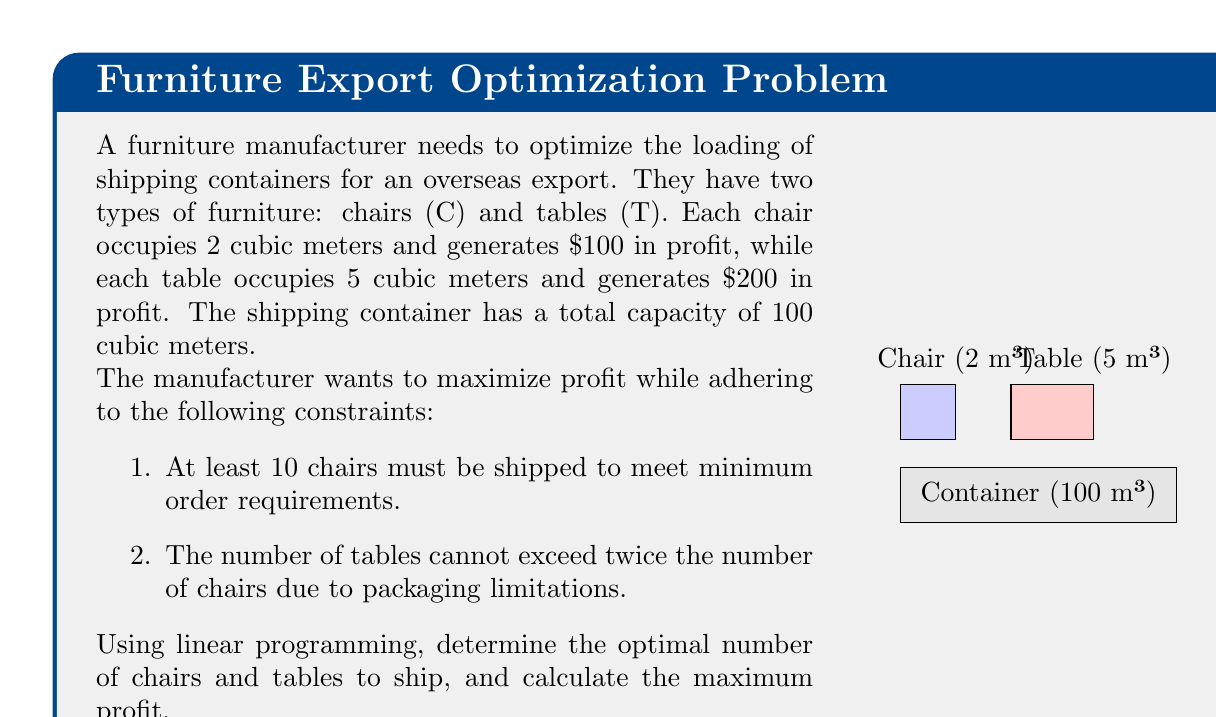Solve this math problem. Let's solve this problem step by step using linear programming:

1. Define variables:
   Let $x$ be the number of chairs and $y$ be the number of tables.

2. Objective function:
   Maximize profit: $Z = 100x + 200y$

3. Constraints:
   a. Space constraint: $2x + 5y \leq 100$ (total space ≤ 100 m³)
   b. Minimum chair requirement: $x \geq 10$
   c. Table-to-chair ratio: $y \leq 2x$
   d. Non-negativity: $x \geq 0, y \geq 0$

4. Set up the linear programming problem:
   Maximize $Z = 100x + 200y$
   Subject to:
   $2x + 5y \leq 100$
   $x \geq 10$
   $y \leq 2x$
   $x, y \geq 0$

5. Solve graphically or using the simplex method. Here, we'll use the corner point method:

   Potential corner points:
   (10, 0), (10, 20), (20, 20), (30, 20), (50, 0)

   Evaluate Z at each point:
   (10, 0):  Z = 1000
   (10, 20): Z = 5000 (infeasible, violates space constraint)
   (20, 20): Z = 6000
   (30, 20): Z = 7000
   (50, 0):  Z = 5000

6. The optimal solution is at (30, 20), meaning 30 chairs and 20 tables.

7. Calculate the maximum profit:
   $Z = 100(30) + 200(20) = 3000 + 4000 = 7000$

Therefore, the optimal solution is to ship 30 chairs and 20 tables, generating a maximum profit of $7000.
Answer: 30 chairs, 20 tables; $7000 profit 